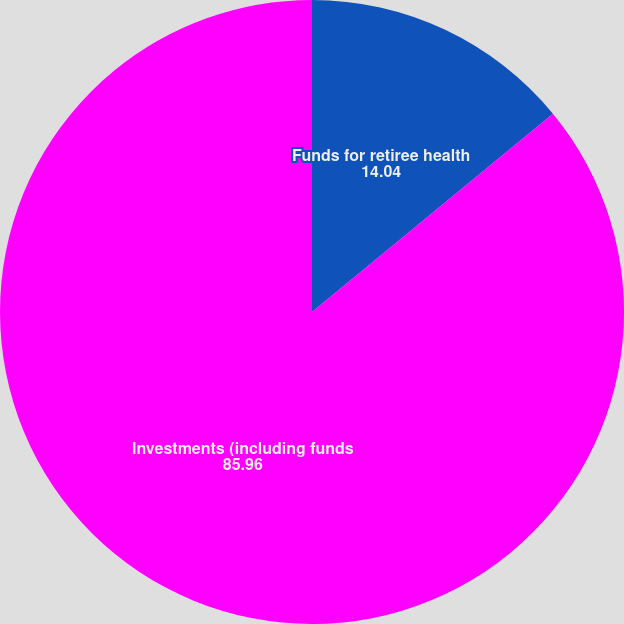<chart> <loc_0><loc_0><loc_500><loc_500><pie_chart><fcel>Funds for retiree health<fcel>Investments (including funds<nl><fcel>14.04%<fcel>85.96%<nl></chart> 